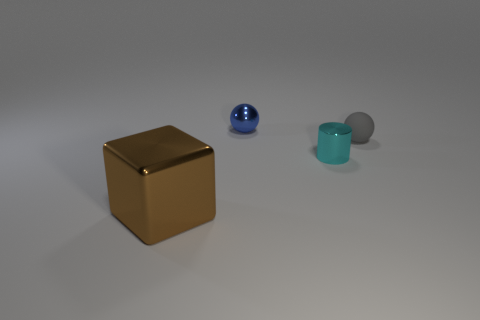Is there any other thing that has the same material as the small cyan cylinder?
Provide a succinct answer. Yes. Are there any other things that are the same size as the blue ball?
Your response must be concise. Yes. What is the material of the thing behind the small ball that is right of the tiny blue sphere?
Provide a short and direct response. Metal. What number of metallic things are tiny blue things or big blocks?
Provide a succinct answer. 2. What is the color of the other thing that is the same shape as the blue shiny object?
Make the answer very short. Gray. How many big objects have the same color as the small metallic sphere?
Offer a terse response. 0. Is there a blue metallic ball that is in front of the ball that is on the right side of the blue ball?
Keep it short and to the point. No. What number of objects are both behind the metallic cylinder and on the right side of the tiny blue metal ball?
Keep it short and to the point. 1. What number of cyan cylinders have the same material as the blue sphere?
Offer a terse response. 1. There is a object that is left of the tiny metallic thing that is behind the small gray thing; what is its size?
Your response must be concise. Large. 